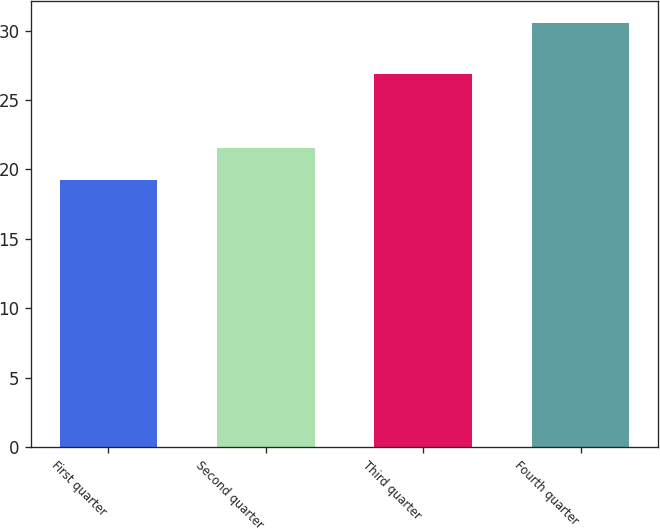Convert chart to OTSL. <chart><loc_0><loc_0><loc_500><loc_500><bar_chart><fcel>First quarter<fcel>Second quarter<fcel>Third quarter<fcel>Fourth quarter<nl><fcel>19.26<fcel>21.56<fcel>26.9<fcel>30.57<nl></chart> 